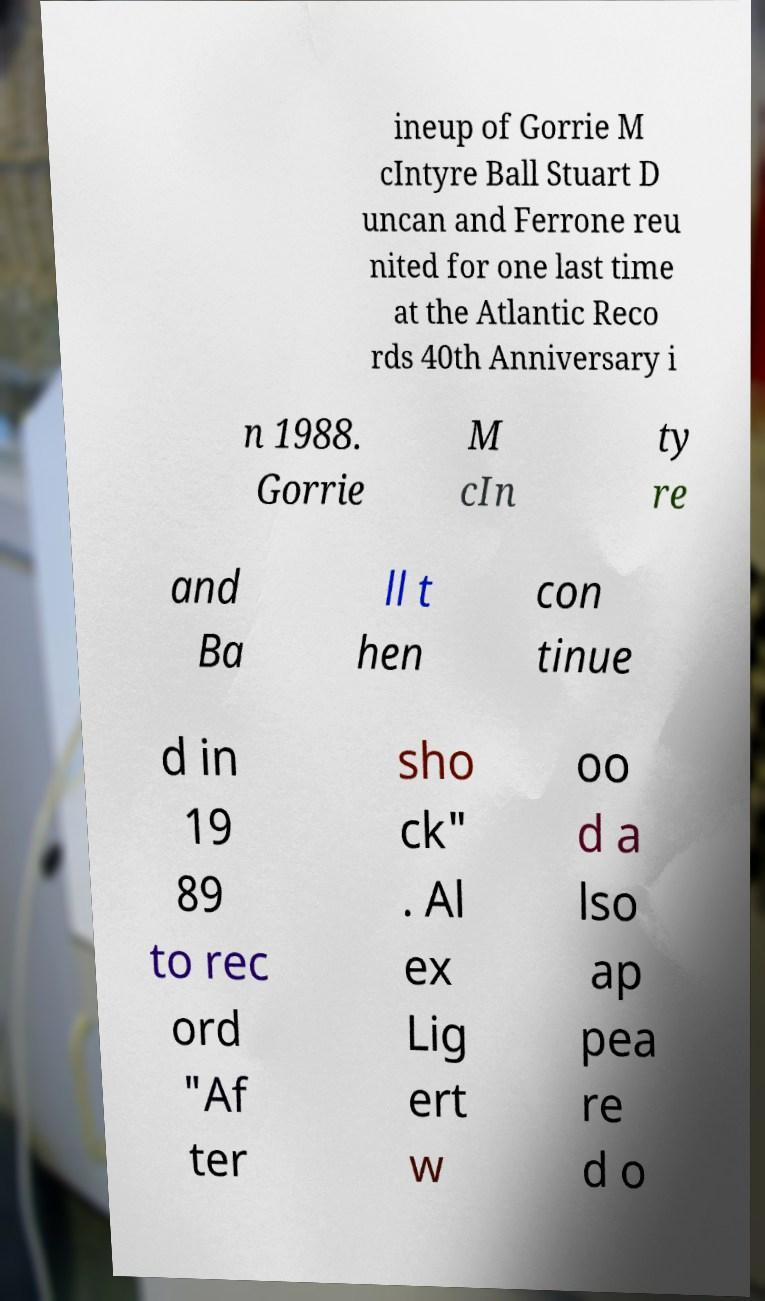Can you read and provide the text displayed in the image?This photo seems to have some interesting text. Can you extract and type it out for me? ineup of Gorrie M cIntyre Ball Stuart D uncan and Ferrone reu nited for one last time at the Atlantic Reco rds 40th Anniversary i n 1988. Gorrie M cIn ty re and Ba ll t hen con tinue d in 19 89 to rec ord "Af ter sho ck" . Al ex Lig ert w oo d a lso ap pea re d o 